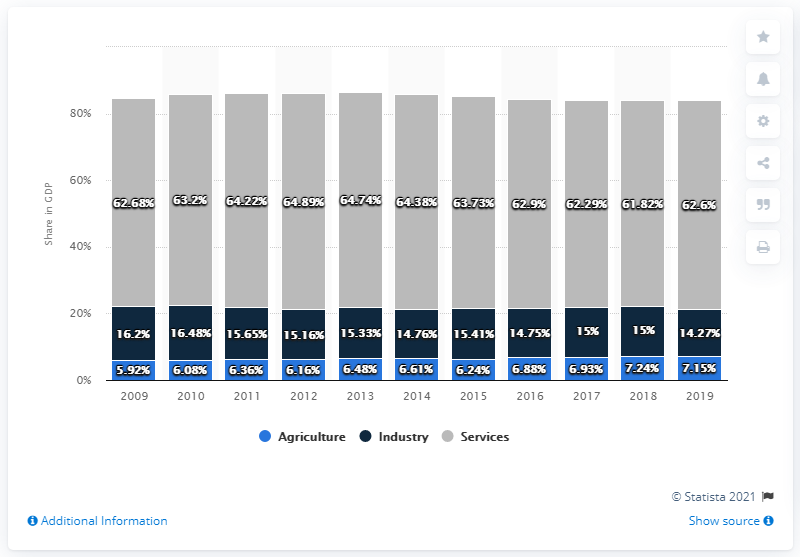Indicate a few pertinent items in this graphic. In 2019, the agriculture sector accounted for 7.15% of the total gross domestic product of St. Vincent and the Grenadines. In 2019, the share of Services in Gross Domestic Product (GDP) was 62.6%. The median value of agriculture's share in GDP is 6.48%. 